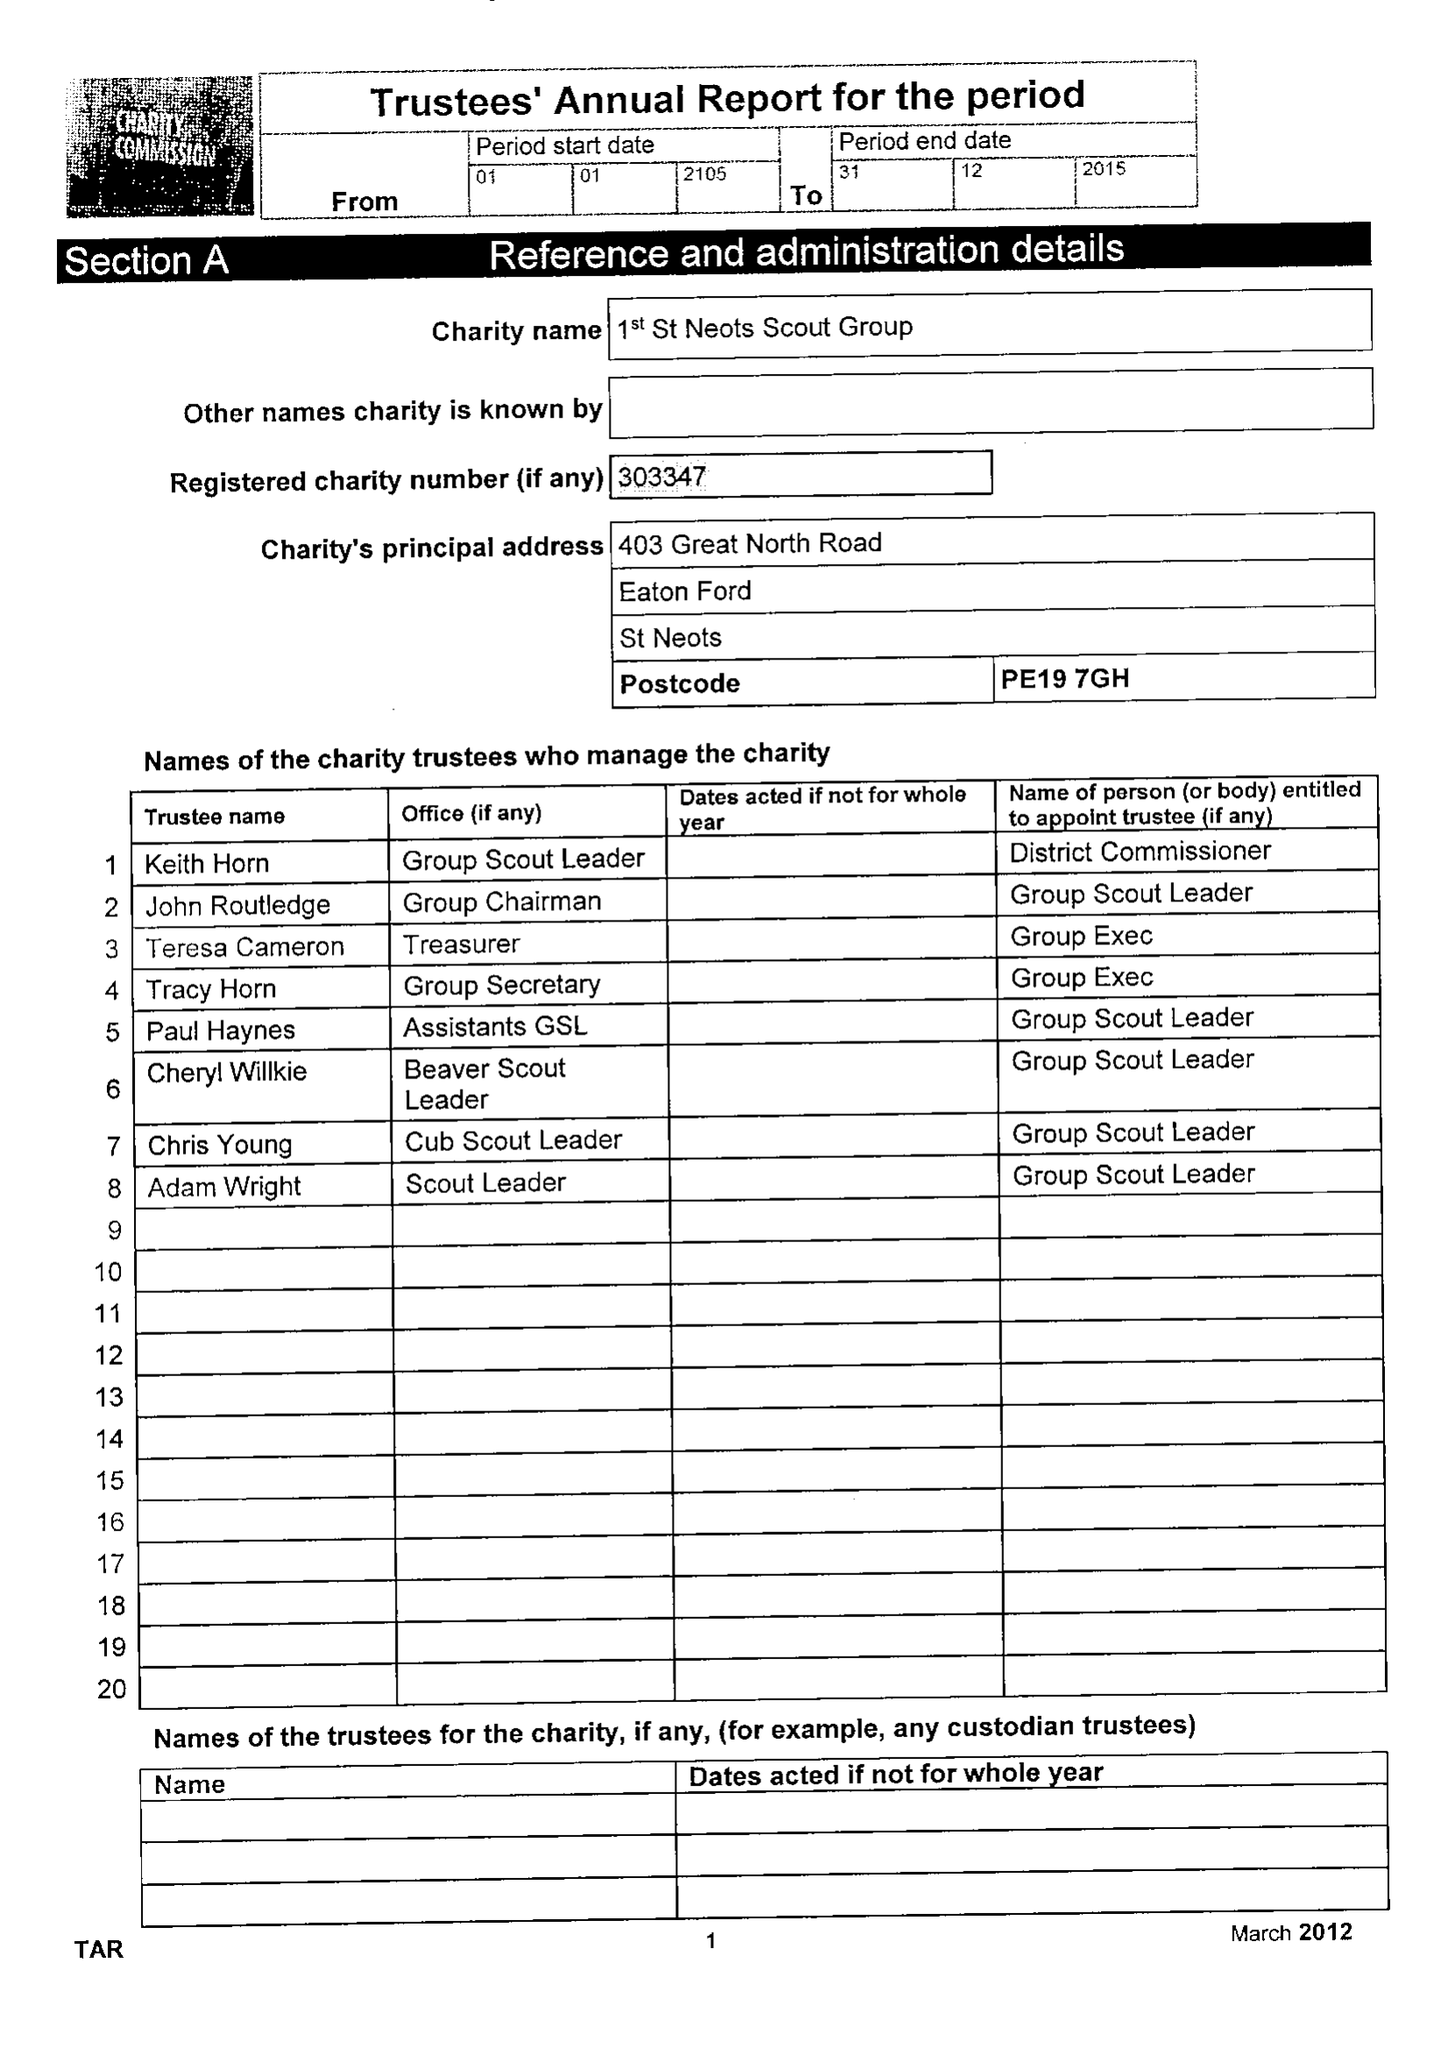What is the value for the spending_annually_in_british_pounds?
Answer the question using a single word or phrase. 28441.06 